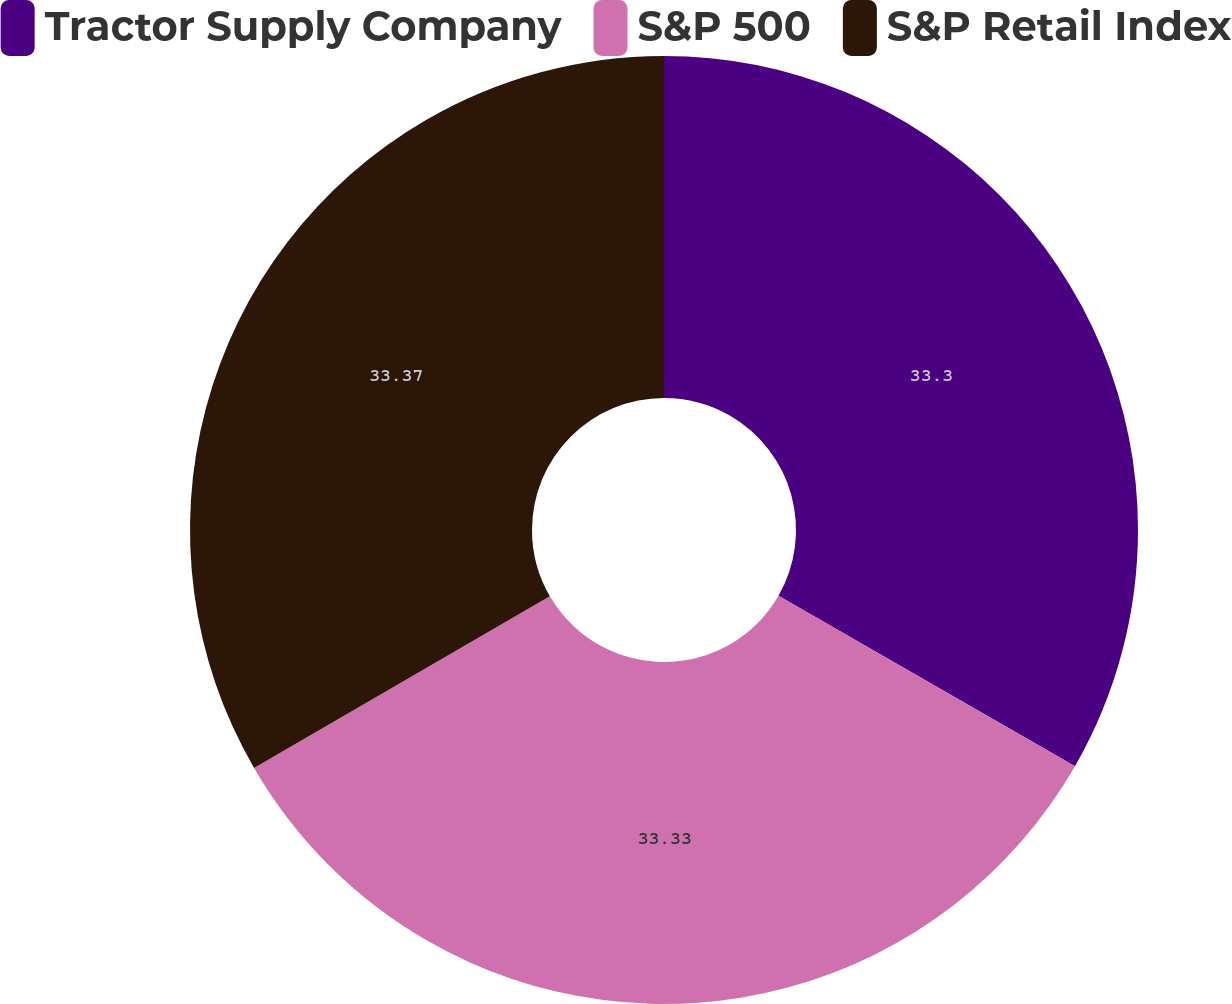<chart> <loc_0><loc_0><loc_500><loc_500><pie_chart><fcel>Tractor Supply Company<fcel>S&P 500<fcel>S&P Retail Index<nl><fcel>33.3%<fcel>33.33%<fcel>33.37%<nl></chart> 